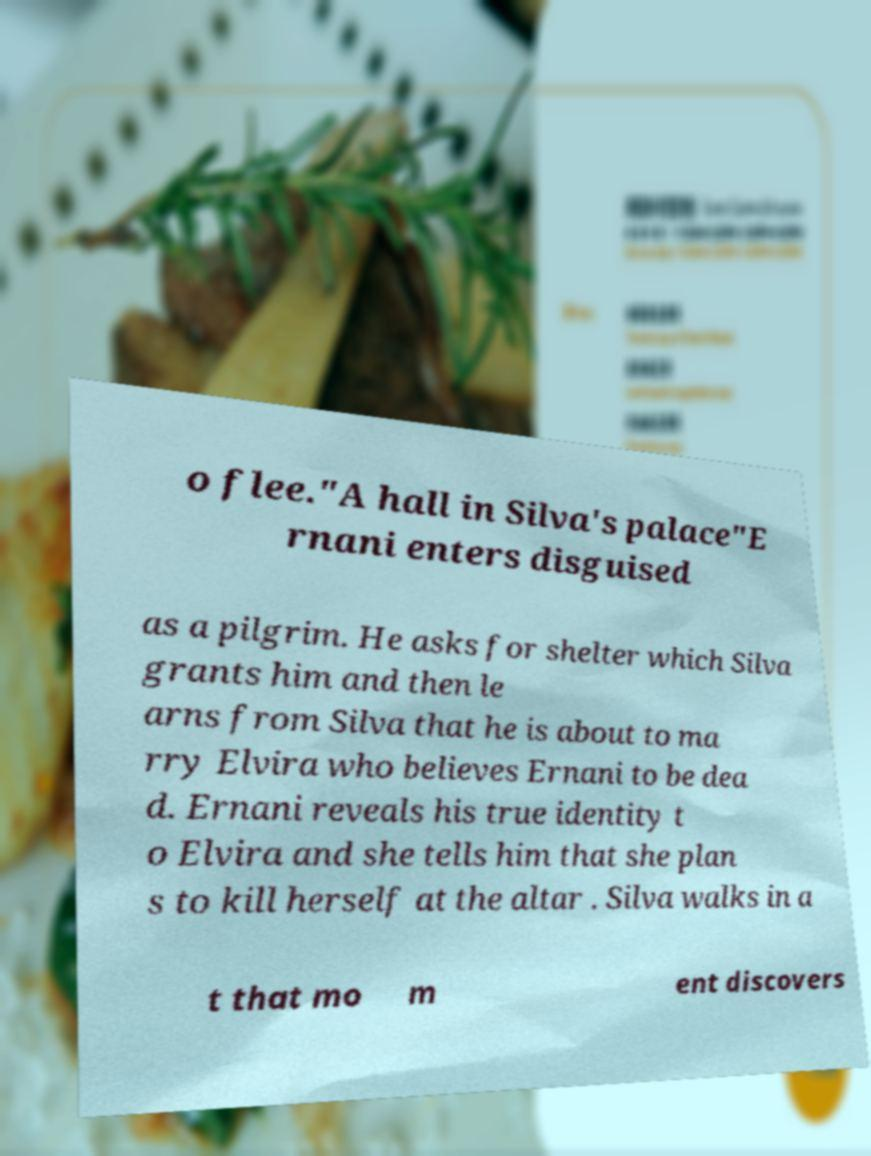There's text embedded in this image that I need extracted. Can you transcribe it verbatim? o flee."A hall in Silva's palace"E rnani enters disguised as a pilgrim. He asks for shelter which Silva grants him and then le arns from Silva that he is about to ma rry Elvira who believes Ernani to be dea d. Ernani reveals his true identity t o Elvira and she tells him that she plan s to kill herself at the altar . Silva walks in a t that mo m ent discovers 